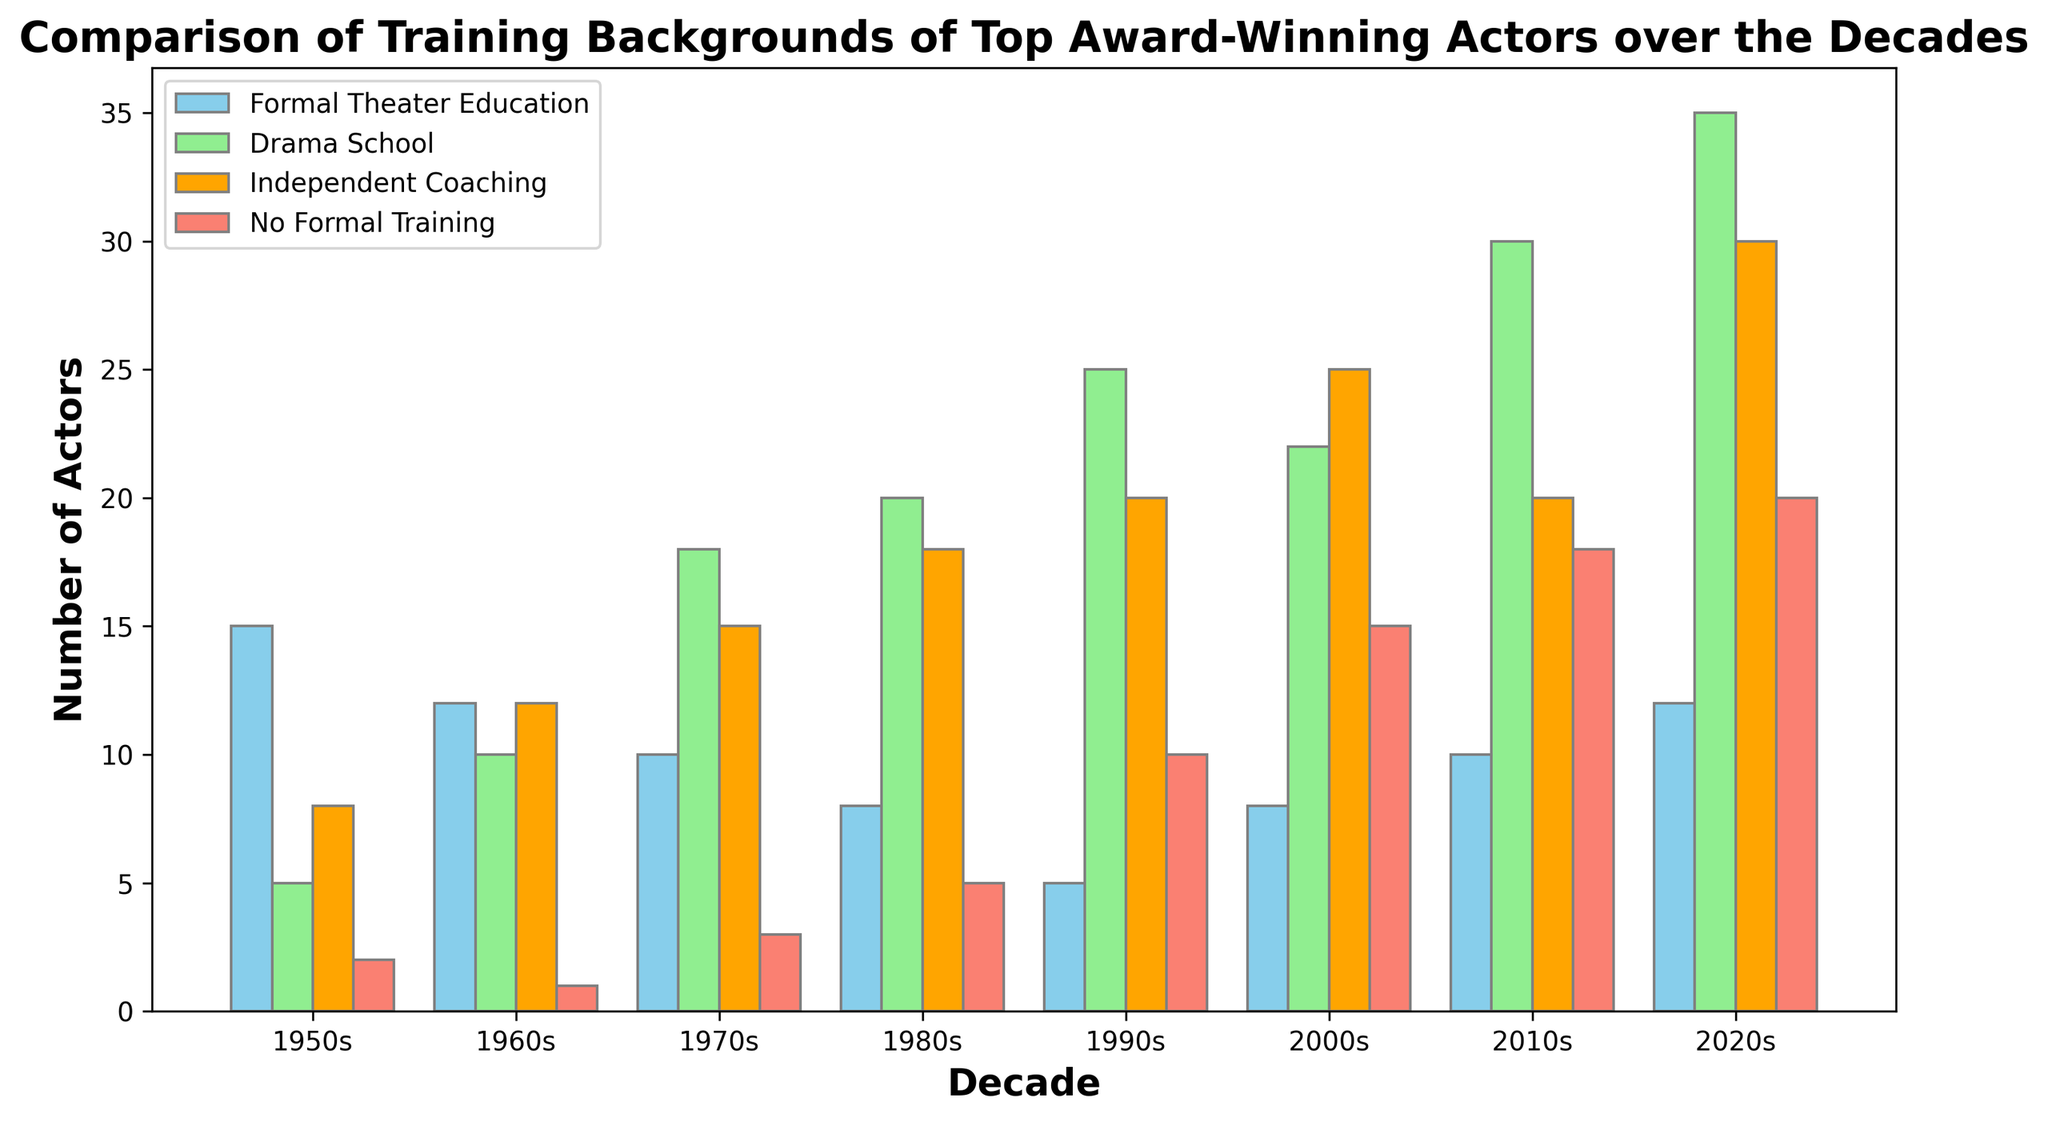Which decade had the highest number of actors with a formal theater education? Look at the bar heights for "Formal Theater Education" across all decades. The bar for the 1950s is the tallest.
Answer: 1950s In which decade did drama school training see the greatest increase compared to the previous decade? Compare the bar heights for "Drama School" between consecutive decades. The increase is greatest from the 1960s to the 1970s (10 to 18).
Answer: 1970s What is the total number of award-winning actors without formal training in the 2010s and 2020s? Add the numbers from the "No Formal Training" category for the 2010s (18) and 2020s (20).
Answer: 38 Which training category had the lowest representation in the 1990s? Look for the shortest bar in the 1990s. The "Formal Theater Education" bar is the shortest.
Answer: Formal Theater Education Did the number of actors with independent coaching increase or decrease from the 1980s to the 2000s? Compare the bar heights for "Independent Coaching" in the 1980s (18) and the 2000s (25). The height increases.
Answer: Increase Which training background saw a consistent increase over every decade from 1950s to 2020s? Identify the category where bars increase in height in every consecutive decade. "Drama School" bars consistently increase.
Answer: Drama School What is the combined total of actors with "Formal Theater Education" and "Drama School" training in the 1980s? Add the numbers for "Formal Theater Education" (8) and "Drama School" (20) in the 1980s.
Answer: 28 How many more actors had independent coaching than no formal training in the 2000s? Subtract the number of actors with "No Formal Training" (15) from those with "Independent Coaching" (25) in the 2000s.
Answer: 10 Which training background had the highest number of actors in the 2020s? Look for the tallest bar in the 2020s. "Drama School" has the tallest bar.
Answer: Drama School How does the number of actors with formal theater education in the 1960s compare to the 1990s? Compare the heights of the "Formal Theater Education" bars for the 1960s (12) and 1990s (5). 1960s is greater.
Answer: 1960s is greater 